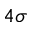<formula> <loc_0><loc_0><loc_500><loc_500>4 \sigma</formula> 